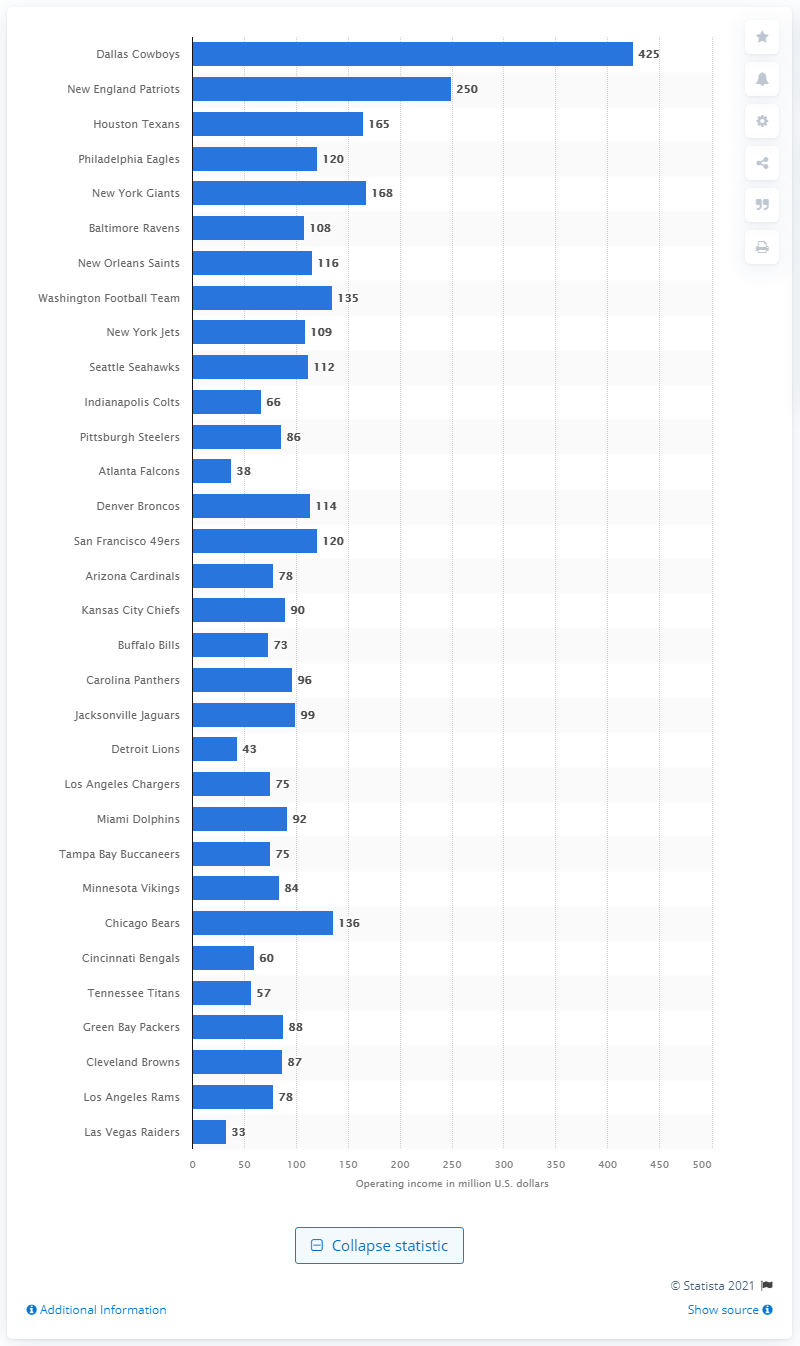Highlight a few significant elements in this photo. The operating income of the Oakland Raiders in 2019 was 33 million dollars. The operating income of the Dallas Cowboys in 2019 was 425. The New England Patriots are the second-largest NFL team. 